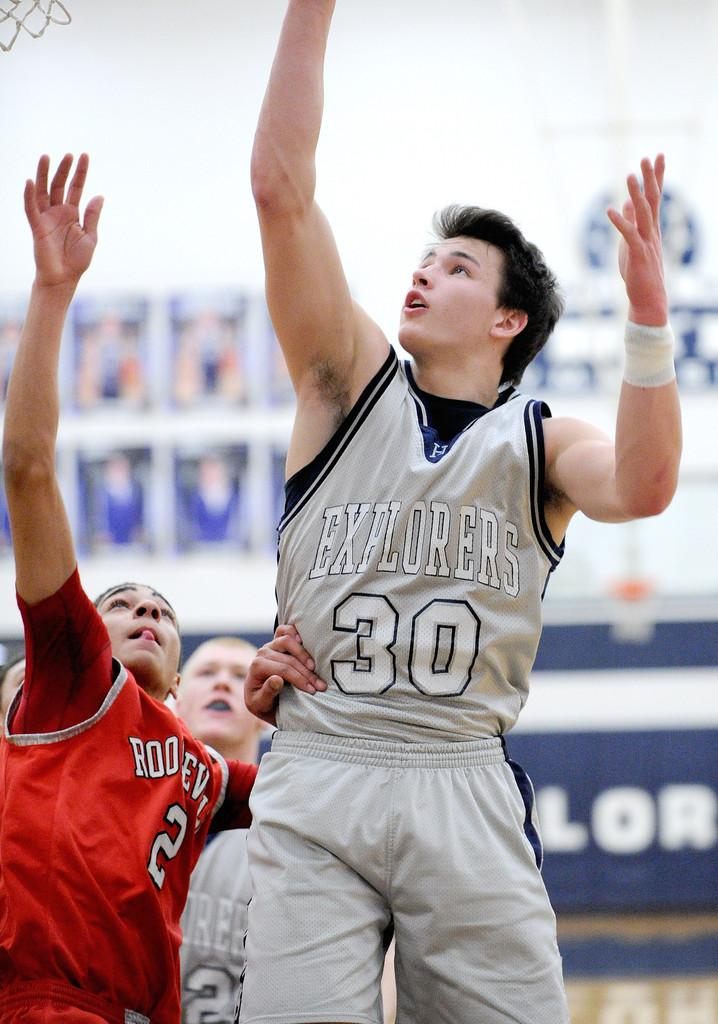Provide a one-sentence caption for the provided image. a bunch of people playing basketball, one of whom has the number thirty on his shirt. 